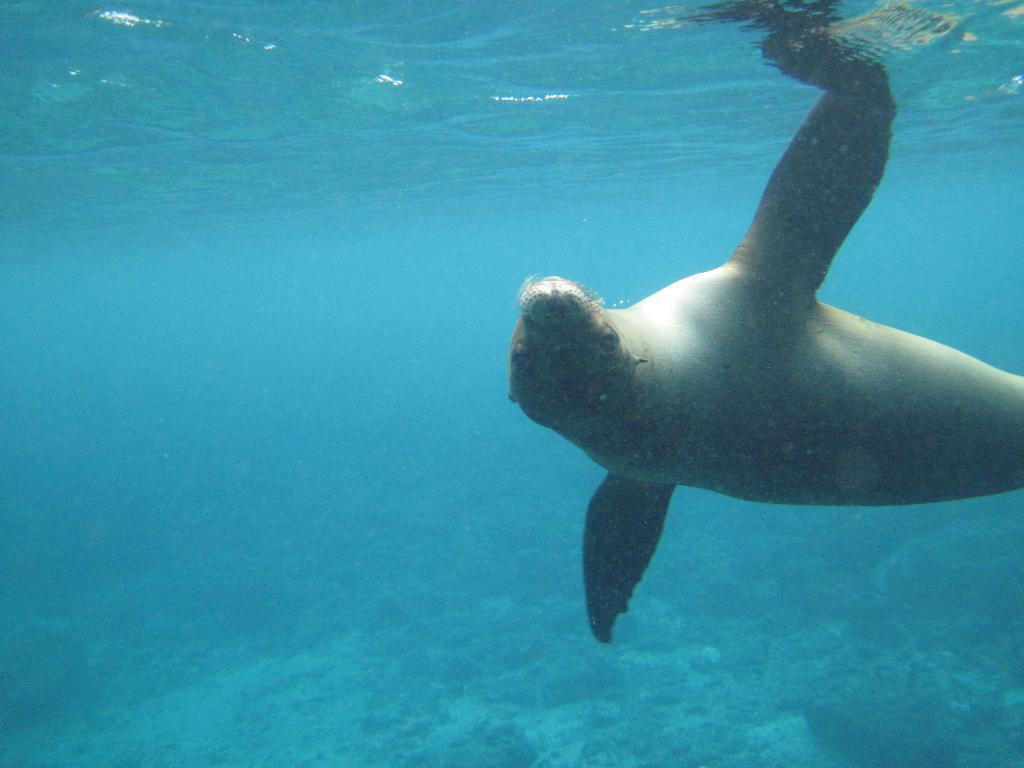Could you give a brief overview of what you see in this image? In this image there is a water animal and water. 